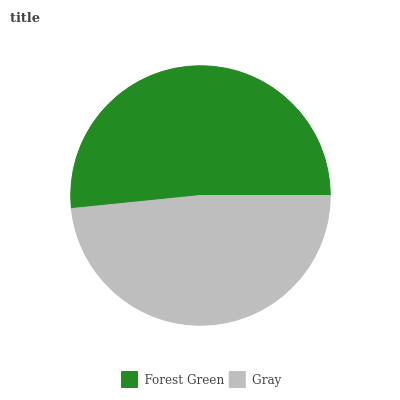Is Gray the minimum?
Answer yes or no. Yes. Is Forest Green the maximum?
Answer yes or no. Yes. Is Gray the maximum?
Answer yes or no. No. Is Forest Green greater than Gray?
Answer yes or no. Yes. Is Gray less than Forest Green?
Answer yes or no. Yes. Is Gray greater than Forest Green?
Answer yes or no. No. Is Forest Green less than Gray?
Answer yes or no. No. Is Forest Green the high median?
Answer yes or no. Yes. Is Gray the low median?
Answer yes or no. Yes. Is Gray the high median?
Answer yes or no. No. Is Forest Green the low median?
Answer yes or no. No. 